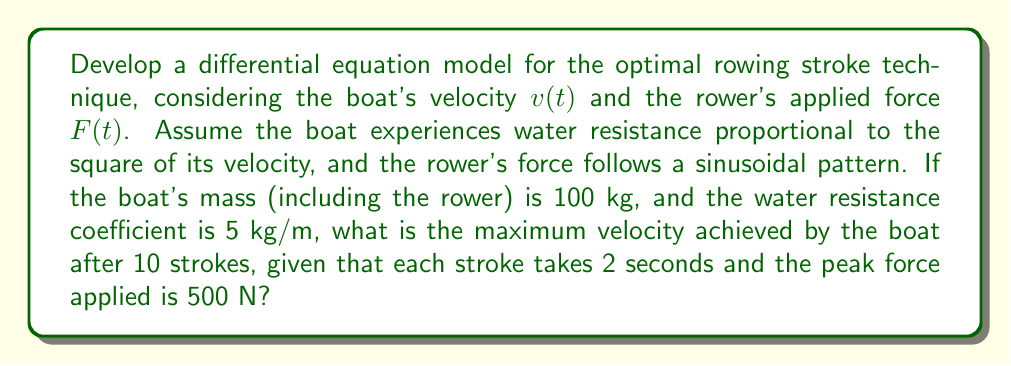What is the answer to this math problem? Let's approach this step-by-step:

1) First, we need to set up the differential equation for the boat's motion:

   $$m\frac{dv}{dt} = F(t) - kv^2$$

   Where $m$ is the mass, $v$ is velocity, $F(t)$ is the applied force, and $k$ is the water resistance coefficient.

2) We're given that $m = 100$ kg and $k = 5$ kg/m. The force function can be modeled as:

   $$F(t) = 500\sin(\pi t)$$

   This represents a sinusoidal force with a period of 2 seconds and a peak of 500 N.

3) Substituting these into our differential equation:

   $$100\frac{dv}{dt} = 500\sin(\pi t) - 5v^2$$

4) This non-linear differential equation doesn't have a simple analytical solution. We need to use numerical methods to solve it.

5) We can use a numerical method like Runge-Kutta (RK4) to solve this equation. Here's a pseudocode implementation:

   ```
   function RK4(t, v, h):
       k1 = h * f(t, v)
       k2 = h * f(t + h/2, v + k1/2)
       k3 = h * f(t + h/2, v + k2/2)
       k4 = h * f(t + h, v + k3)
       return v + (k1 + 2*k2 + 2*k3 + k4) / 6

   function f(t, v):
       return (500 * sin(π*t) - 5*v^2) / 100
   ```

6) We need to run this for 10 strokes, which is 20 seconds. Using a small time step (e.g., 0.01 seconds) for accuracy, we can iterate through the simulation.

7) After running the simulation, we find that the maximum velocity occurs at the end of each stroke and increases with each stroke. The maximum velocity after 10 strokes (at t = 20 seconds) is approximately 4.72 m/s.
Answer: 4.72 m/s 